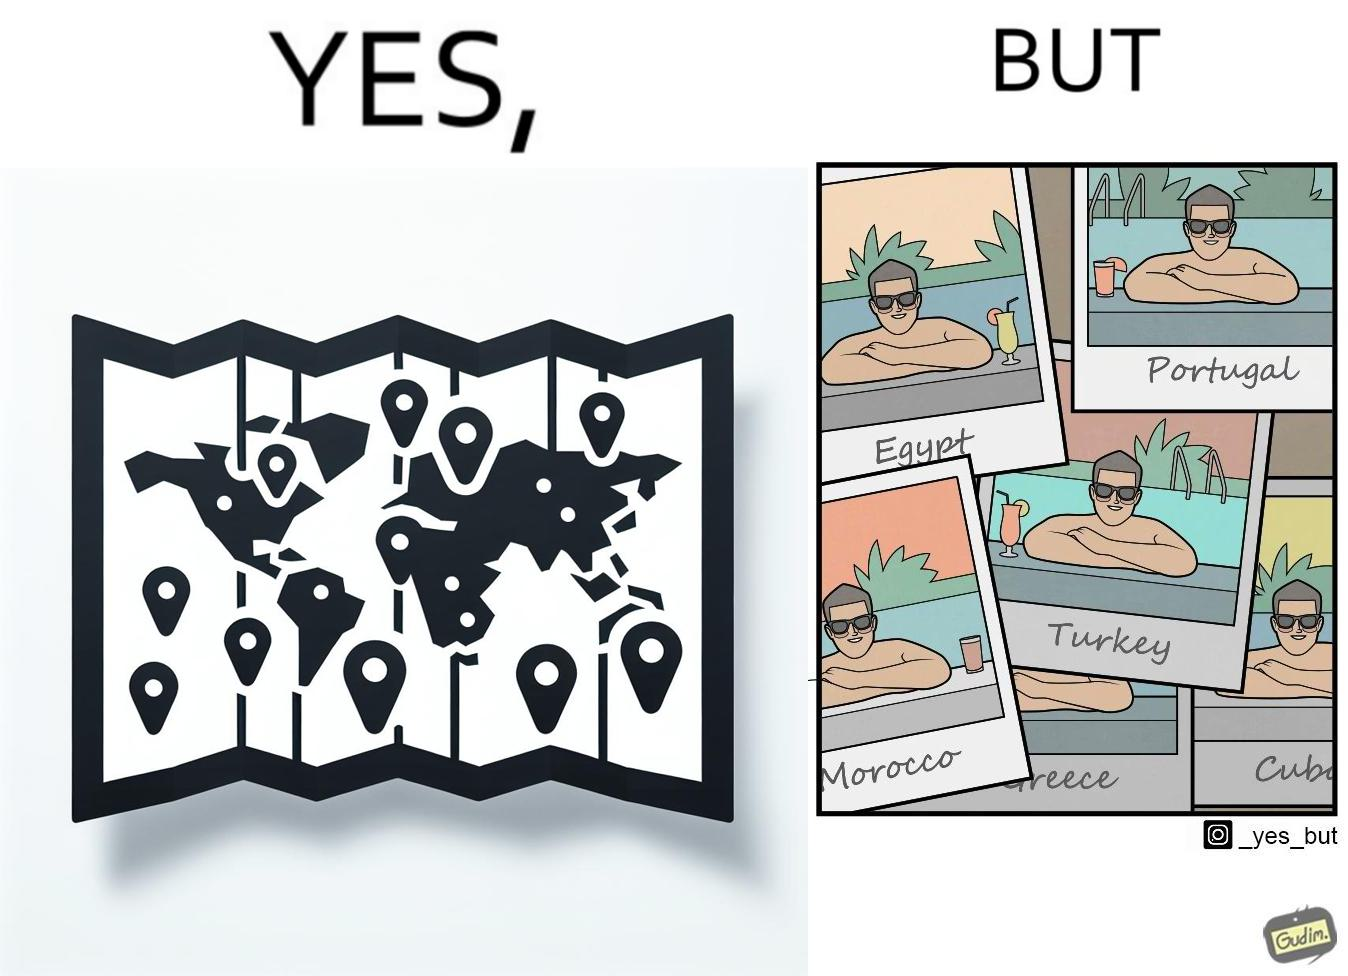What is the satirical meaning behind this image? The image is satirical because while the man has visited all the place marked on the map, he only seems to have swam in pools in all these differnt countries and has not actually seen these places. 